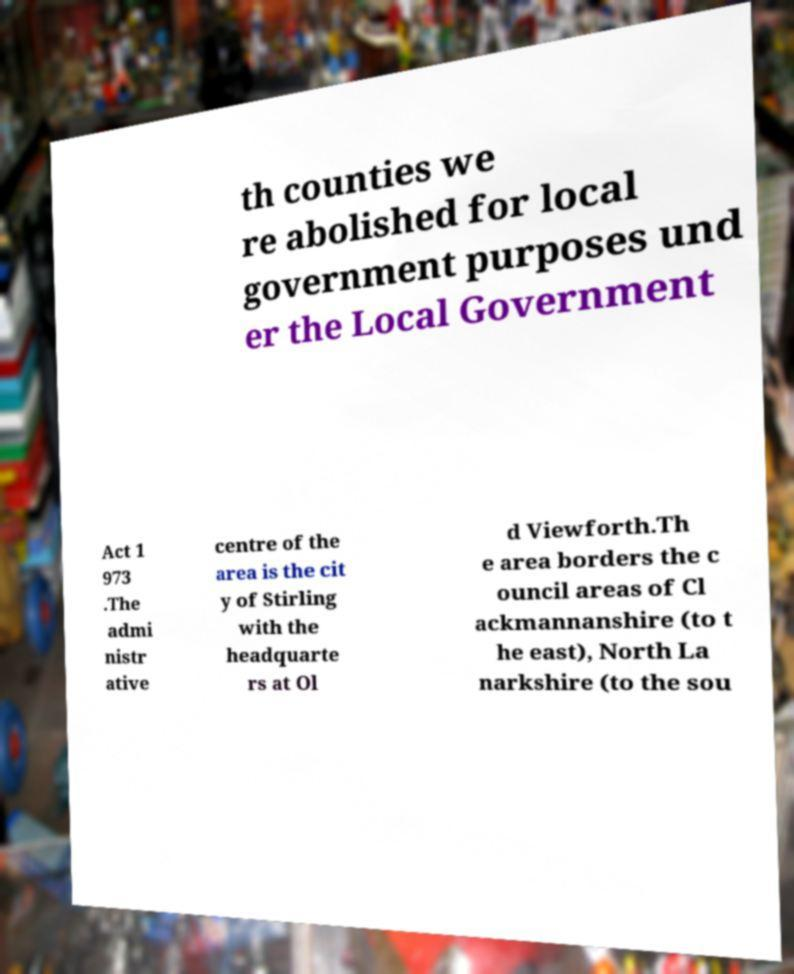I need the written content from this picture converted into text. Can you do that? th counties we re abolished for local government purposes und er the Local Government Act 1 973 .The admi nistr ative centre of the area is the cit y of Stirling with the headquarte rs at Ol d Viewforth.Th e area borders the c ouncil areas of Cl ackmannanshire (to t he east), North La narkshire (to the sou 